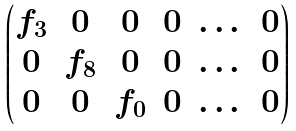Convert formula to latex. <formula><loc_0><loc_0><loc_500><loc_500>\begin{pmatrix} f _ { 3 } & 0 & 0 & 0 & \dots & 0 \\ 0 & f _ { 8 } & 0 & 0 & \dots & 0 \\ 0 & 0 & f _ { 0 } & 0 & \dots & 0 \\ \end{pmatrix}</formula> 